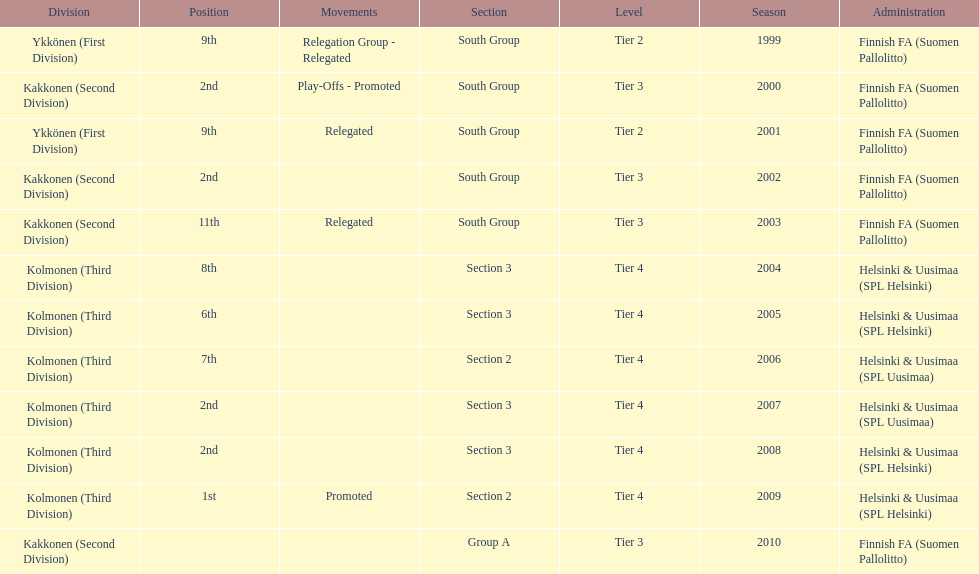How many tiers had more than one relegated movement? 1. 